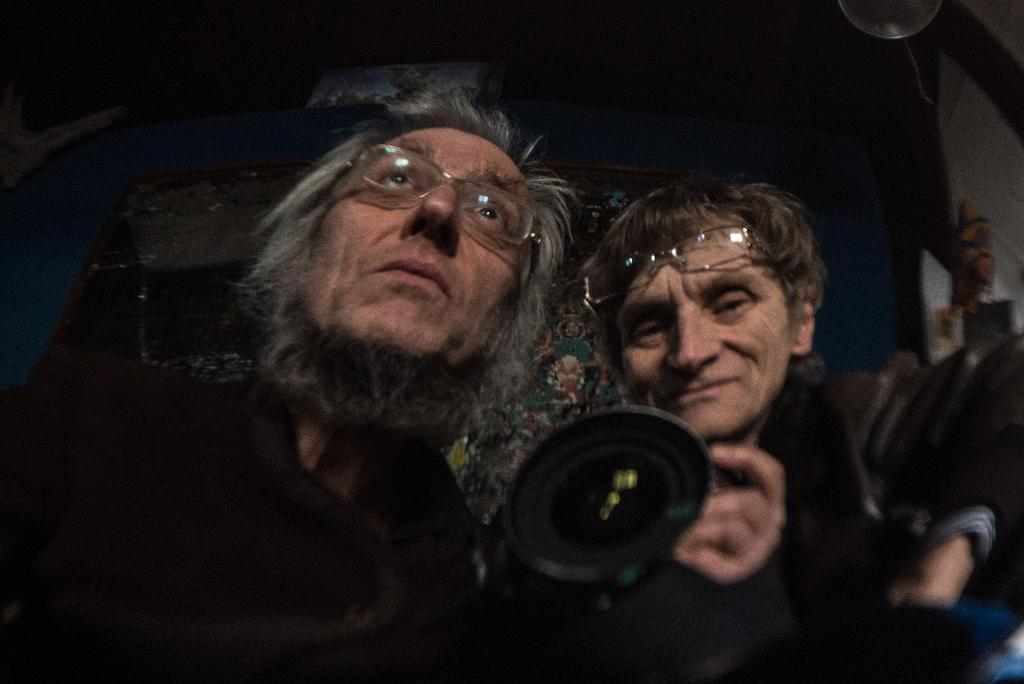How many people are in the image? There are two persons in the image. What are the two persons doing in the image? The two persons are sitting. What are the two persons holding in the image? The two persons are holding a camera. What type of club is the mother using to hit the ball in the image? There is no mother or club present in the image. The image features two persons sitting and holding a camera. 